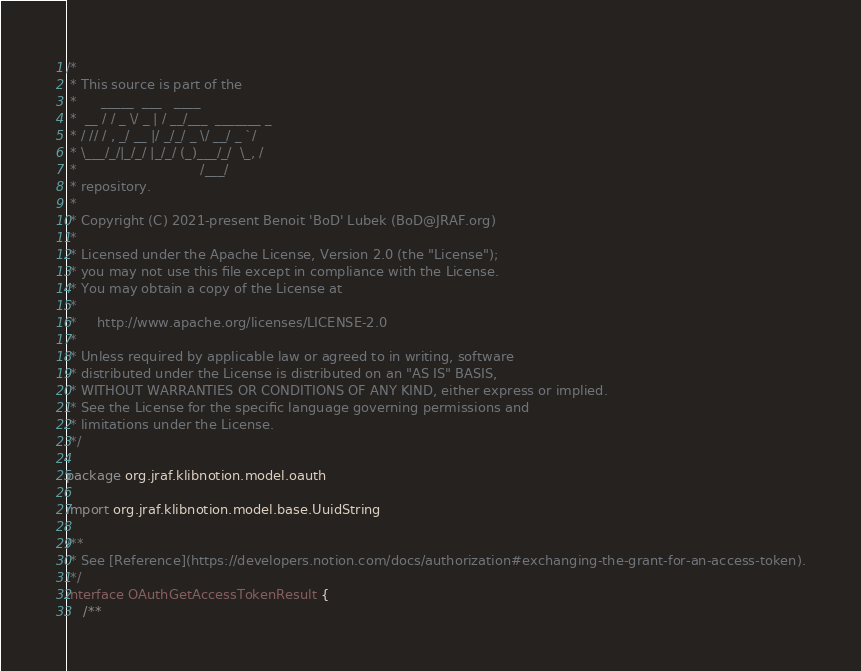<code> <loc_0><loc_0><loc_500><loc_500><_Kotlin_>/*
 * This source is part of the
 *      _____  ___   ____
 *  __ / / _ \/ _ | / __/___  _______ _
 * / // / , _/ __ |/ _/_/ _ \/ __/ _ `/
 * \___/_/|_/_/ |_/_/ (_)___/_/  \_, /
 *                              /___/
 * repository.
 *
 * Copyright (C) 2021-present Benoit 'BoD' Lubek (BoD@JRAF.org)
 *
 * Licensed under the Apache License, Version 2.0 (the "License");
 * you may not use this file except in compliance with the License.
 * You may obtain a copy of the License at
 *
 *     http://www.apache.org/licenses/LICENSE-2.0
 *
 * Unless required by applicable law or agreed to in writing, software
 * distributed under the License is distributed on an "AS IS" BASIS,
 * WITHOUT WARRANTIES OR CONDITIONS OF ANY KIND, either express or implied.
 * See the License for the specific language governing permissions and
 * limitations under the License.
 */

package org.jraf.klibnotion.model.oauth

import org.jraf.klibnotion.model.base.UuidString

/**
 * See [Reference](https://developers.notion.com/docs/authorization#exchanging-the-grant-for-an-access-token).
 */
interface OAuthGetAccessTokenResult {
    /**</code> 